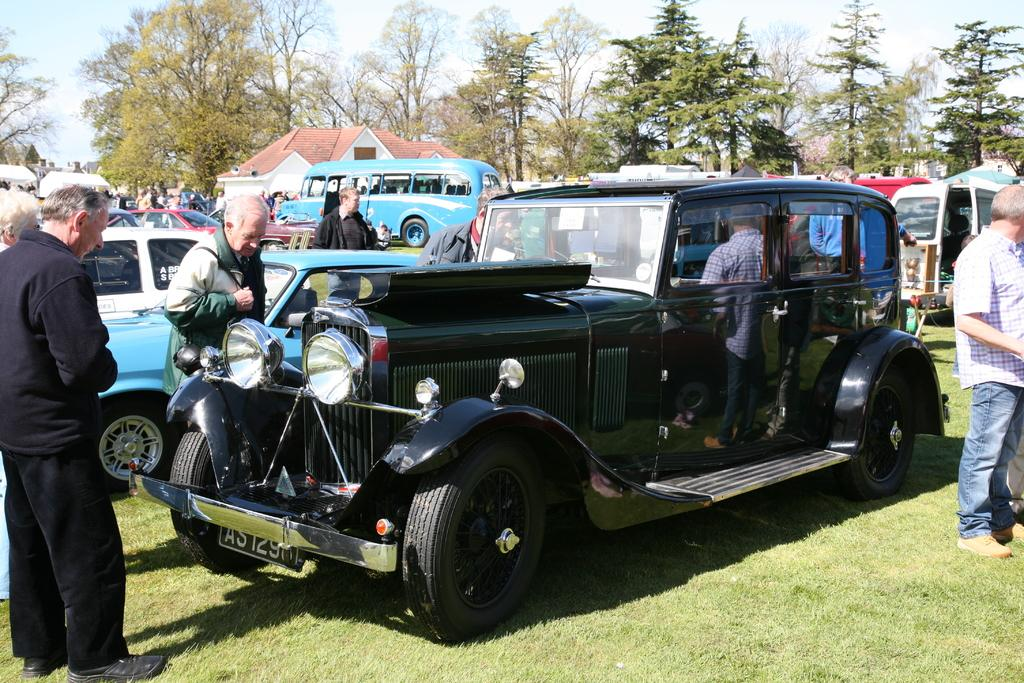What can be seen in the foreground of the picture? In the foreground of the picture, there are cars, people, and grass. Can you describe the people in the foreground? There are people in the foreground of the picture, but their specific actions or appearances are not mentioned in the facts. What is located in the center of the picture? In the center of the picture, there are people, vehicles, trees, and a building. How is the weather in the image? The sky is sunny, which suggests good weather. What is the name of the person standing next to the plough in the image? There is no plough present in the image, and therefore no person standing next to it. Which direction is the north located in the image? The facts provided do not give any information about the direction or orientation of the image, so it is impossible to determine the location of the north. 